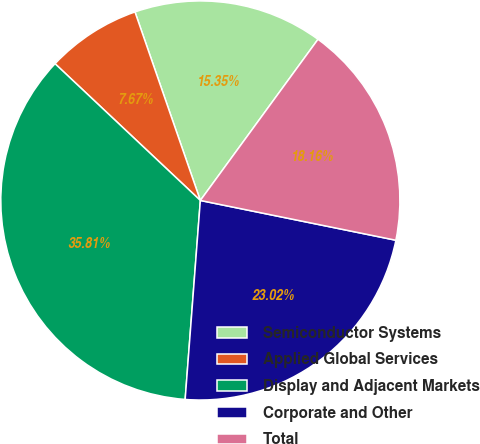<chart> <loc_0><loc_0><loc_500><loc_500><pie_chart><fcel>Semiconductor Systems<fcel>Applied Global Services<fcel>Display and Adjacent Markets<fcel>Corporate and Other<fcel>Total<nl><fcel>15.35%<fcel>7.67%<fcel>35.81%<fcel>23.02%<fcel>18.16%<nl></chart> 